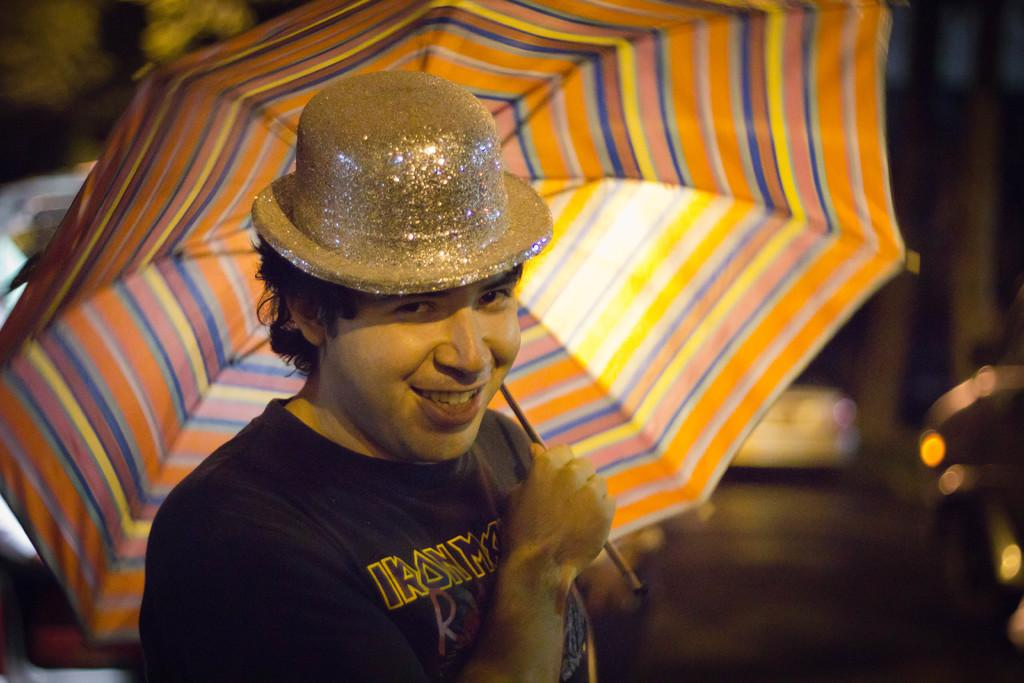Who is the main subject in the image? There is a man in the center of the image. What is the man doing in the image? The man is standing in the image. What object is the man holding in the image? The man is holding an umbrella in the image. What type of headwear is the man wearing in the image? The man is wearing a hat in the image. What can be seen in the background of the image? There are vehicles and trees in the background of the image. What type of vase is on the table next to the man in the image? There is no vase present in the image; the man is holding an umbrella. What type of eggnog is the man drinking in the image? There is no eggnog present in the image; the man is holding an umbrella. 